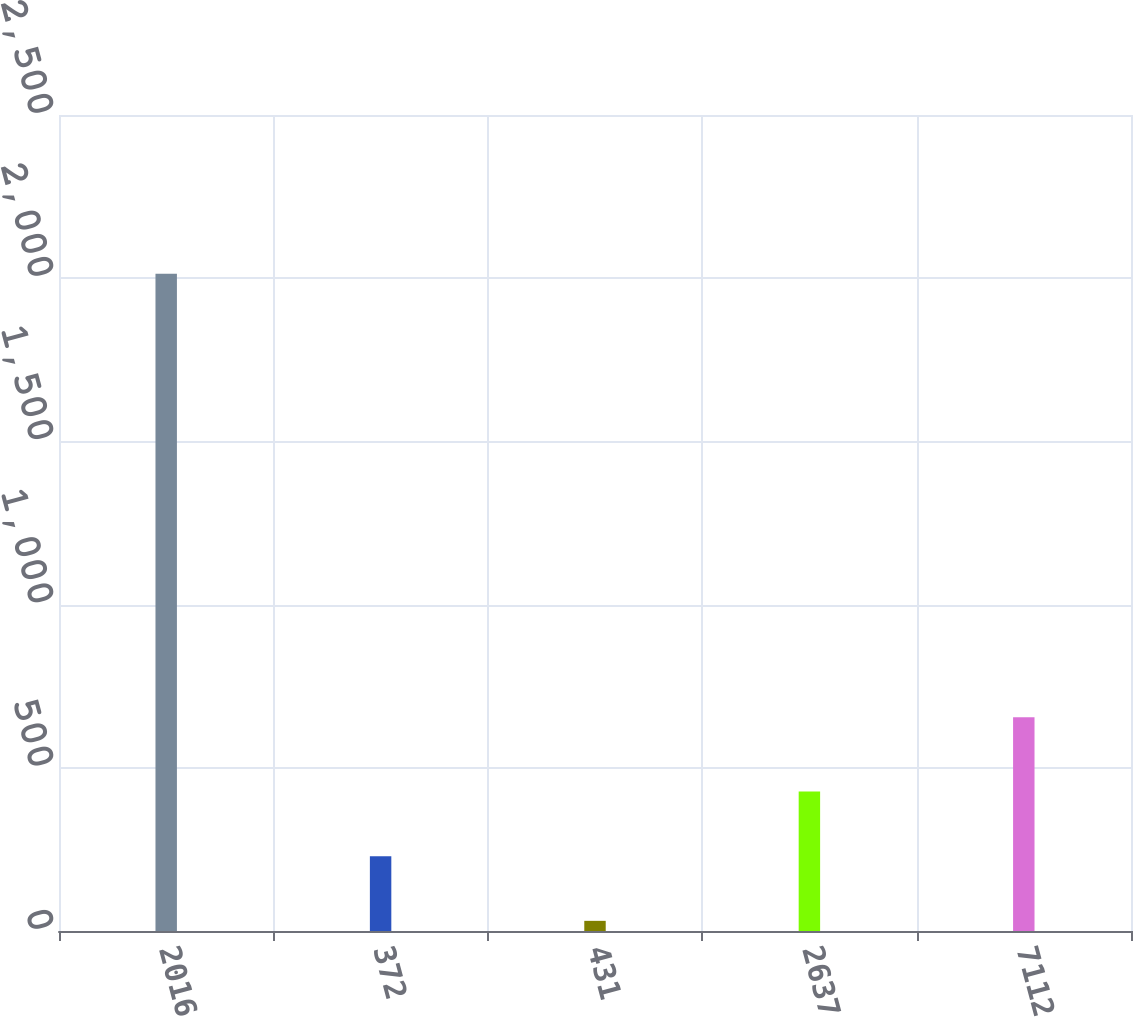Convert chart to OTSL. <chart><loc_0><loc_0><loc_500><loc_500><bar_chart><fcel>2016<fcel>372<fcel>431<fcel>2637<fcel>7112<nl><fcel>2014<fcel>229.39<fcel>31.1<fcel>427.68<fcel>655.1<nl></chart> 